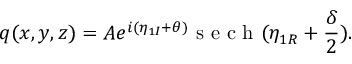<formula> <loc_0><loc_0><loc_500><loc_500>q ( x , y , z ) = A e ^ { i ( \eta _ { 1 I } + \theta ) } s e c h ( \eta _ { 1 R } + \frac { \delta } { 2 } ) .</formula> 